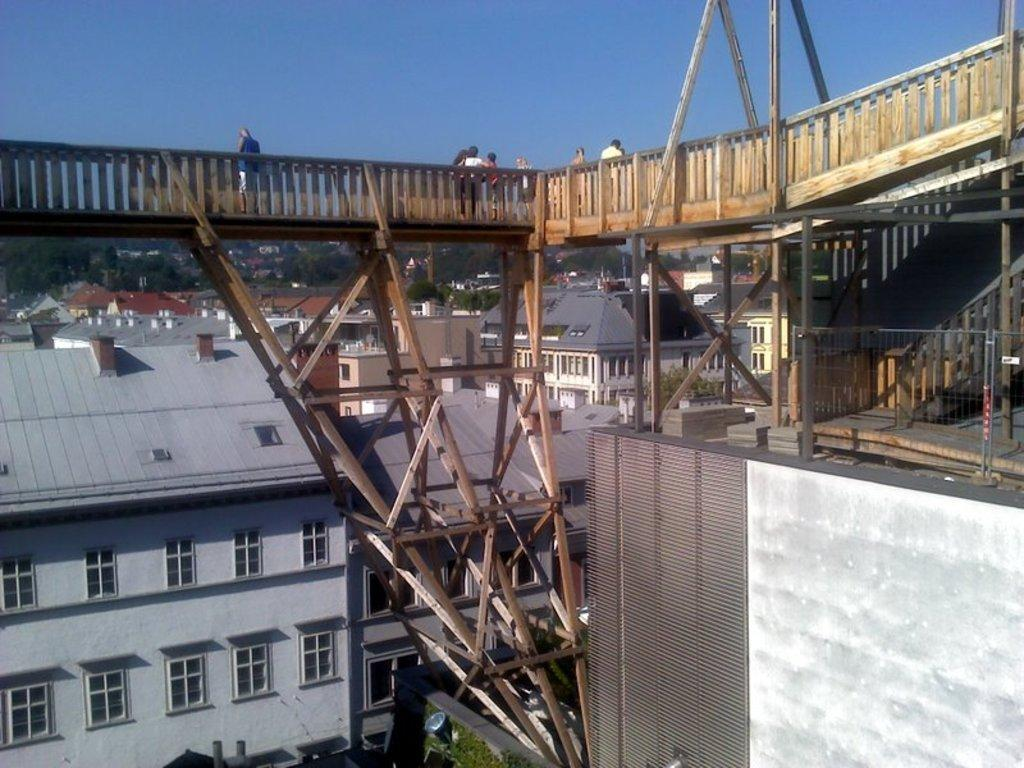What type of material is used for the railing in the image? The wooden railing in the image is made of wood. Can you describe the people in the image? There are people in the image, but their specific actions or characteristics are not mentioned in the facts. What other wooden structures can be seen in the image? There are wooden poles visible in the image. What type of barrier is present in the image? There is fencing in the image. What can be seen in the background of the image? The background of the image includes buildings, trees, windows, walls, and the sky. How does the leaf help the expert in the image? There is no leaf or expert present in the image. What type of cough does the person in the image have? There is no mention of a cough or a person with a cough in the image. 